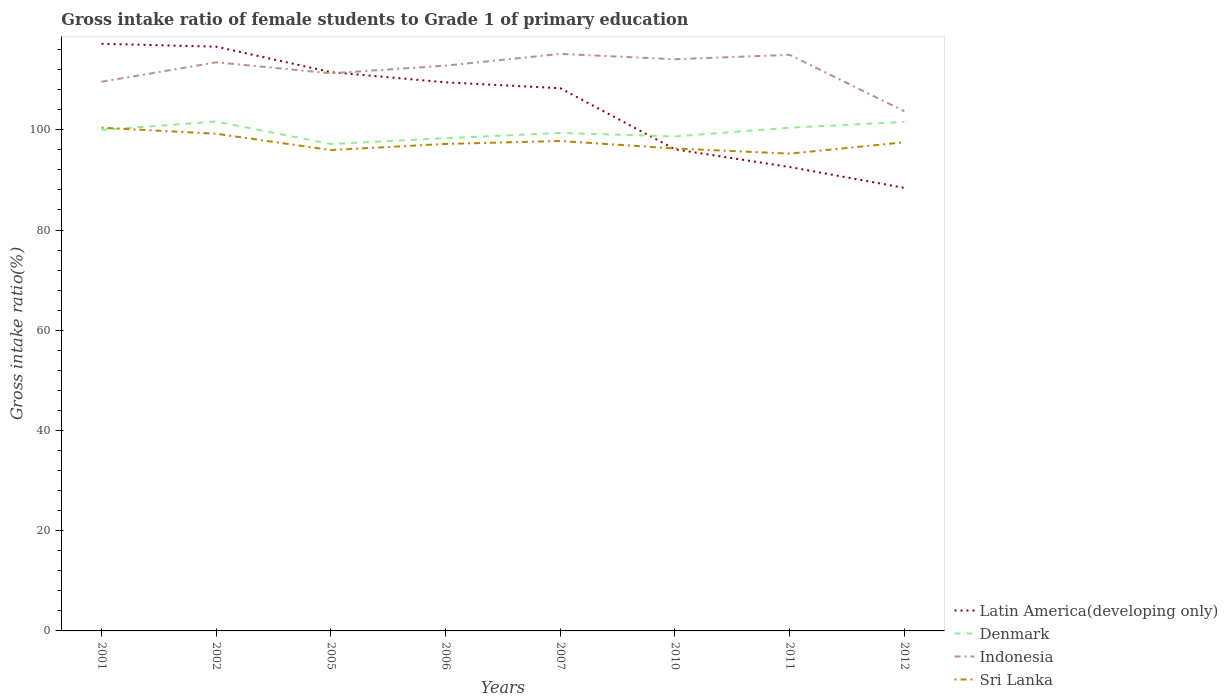Does the line corresponding to Denmark intersect with the line corresponding to Sri Lanka?
Keep it short and to the point. Yes. Across all years, what is the maximum gross intake ratio in Latin America(developing only)?
Your answer should be compact. 88.41. What is the total gross intake ratio in Sri Lanka in the graph?
Provide a short and direct response. 0.71. What is the difference between the highest and the second highest gross intake ratio in Denmark?
Provide a succinct answer. 4.5. What is the difference between the highest and the lowest gross intake ratio in Denmark?
Ensure brevity in your answer.  4. Is the gross intake ratio in Indonesia strictly greater than the gross intake ratio in Sri Lanka over the years?
Offer a very short reply. No. How many lines are there?
Give a very brief answer. 4. What is the difference between two consecutive major ticks on the Y-axis?
Your answer should be very brief. 20. How many legend labels are there?
Your response must be concise. 4. What is the title of the graph?
Give a very brief answer. Gross intake ratio of female students to Grade 1 of primary education. Does "Latin America(all income levels)" appear as one of the legend labels in the graph?
Your answer should be compact. No. What is the label or title of the Y-axis?
Provide a succinct answer. Gross intake ratio(%). What is the Gross intake ratio(%) of Latin America(developing only) in 2001?
Your answer should be very brief. 117.17. What is the Gross intake ratio(%) in Denmark in 2001?
Provide a succinct answer. 99.98. What is the Gross intake ratio(%) of Indonesia in 2001?
Ensure brevity in your answer.  109.59. What is the Gross intake ratio(%) in Sri Lanka in 2001?
Your answer should be very brief. 100.42. What is the Gross intake ratio(%) of Latin America(developing only) in 2002?
Give a very brief answer. 116.59. What is the Gross intake ratio(%) in Denmark in 2002?
Keep it short and to the point. 101.65. What is the Gross intake ratio(%) in Indonesia in 2002?
Provide a succinct answer. 113.46. What is the Gross intake ratio(%) in Sri Lanka in 2002?
Make the answer very short. 99.21. What is the Gross intake ratio(%) in Latin America(developing only) in 2005?
Your answer should be very brief. 111.51. What is the Gross intake ratio(%) in Denmark in 2005?
Your response must be concise. 97.15. What is the Gross intake ratio(%) of Indonesia in 2005?
Keep it short and to the point. 111.28. What is the Gross intake ratio(%) of Sri Lanka in 2005?
Give a very brief answer. 95.96. What is the Gross intake ratio(%) in Latin America(developing only) in 2006?
Keep it short and to the point. 109.47. What is the Gross intake ratio(%) of Denmark in 2006?
Your answer should be very brief. 98.34. What is the Gross intake ratio(%) in Indonesia in 2006?
Ensure brevity in your answer.  112.8. What is the Gross intake ratio(%) of Sri Lanka in 2006?
Your response must be concise. 97.18. What is the Gross intake ratio(%) in Latin America(developing only) in 2007?
Ensure brevity in your answer.  108.3. What is the Gross intake ratio(%) of Denmark in 2007?
Make the answer very short. 99.37. What is the Gross intake ratio(%) of Indonesia in 2007?
Give a very brief answer. 115.14. What is the Gross intake ratio(%) of Sri Lanka in 2007?
Offer a terse response. 97.76. What is the Gross intake ratio(%) in Latin America(developing only) in 2010?
Ensure brevity in your answer.  96.11. What is the Gross intake ratio(%) in Denmark in 2010?
Keep it short and to the point. 98.68. What is the Gross intake ratio(%) in Indonesia in 2010?
Your answer should be compact. 114.08. What is the Gross intake ratio(%) of Sri Lanka in 2010?
Give a very brief answer. 96.27. What is the Gross intake ratio(%) in Latin America(developing only) in 2011?
Your answer should be compact. 92.57. What is the Gross intake ratio(%) in Denmark in 2011?
Ensure brevity in your answer.  100.42. What is the Gross intake ratio(%) of Indonesia in 2011?
Offer a very short reply. 114.96. What is the Gross intake ratio(%) in Sri Lanka in 2011?
Offer a very short reply. 95.25. What is the Gross intake ratio(%) in Latin America(developing only) in 2012?
Ensure brevity in your answer.  88.41. What is the Gross intake ratio(%) of Denmark in 2012?
Give a very brief answer. 101.57. What is the Gross intake ratio(%) in Indonesia in 2012?
Make the answer very short. 103.7. What is the Gross intake ratio(%) of Sri Lanka in 2012?
Your answer should be very brief. 97.51. Across all years, what is the maximum Gross intake ratio(%) in Latin America(developing only)?
Ensure brevity in your answer.  117.17. Across all years, what is the maximum Gross intake ratio(%) of Denmark?
Provide a succinct answer. 101.65. Across all years, what is the maximum Gross intake ratio(%) of Indonesia?
Give a very brief answer. 115.14. Across all years, what is the maximum Gross intake ratio(%) of Sri Lanka?
Your answer should be very brief. 100.42. Across all years, what is the minimum Gross intake ratio(%) in Latin America(developing only)?
Provide a short and direct response. 88.41. Across all years, what is the minimum Gross intake ratio(%) of Denmark?
Give a very brief answer. 97.15. Across all years, what is the minimum Gross intake ratio(%) of Indonesia?
Your answer should be compact. 103.7. Across all years, what is the minimum Gross intake ratio(%) in Sri Lanka?
Offer a very short reply. 95.25. What is the total Gross intake ratio(%) of Latin America(developing only) in the graph?
Offer a very short reply. 840.12. What is the total Gross intake ratio(%) of Denmark in the graph?
Ensure brevity in your answer.  797.16. What is the total Gross intake ratio(%) in Indonesia in the graph?
Provide a succinct answer. 895.02. What is the total Gross intake ratio(%) in Sri Lanka in the graph?
Your response must be concise. 779.56. What is the difference between the Gross intake ratio(%) of Latin America(developing only) in 2001 and that in 2002?
Ensure brevity in your answer.  0.58. What is the difference between the Gross intake ratio(%) in Denmark in 2001 and that in 2002?
Keep it short and to the point. -1.67. What is the difference between the Gross intake ratio(%) in Indonesia in 2001 and that in 2002?
Provide a succinct answer. -3.88. What is the difference between the Gross intake ratio(%) of Sri Lanka in 2001 and that in 2002?
Provide a short and direct response. 1.2. What is the difference between the Gross intake ratio(%) of Latin America(developing only) in 2001 and that in 2005?
Provide a short and direct response. 5.66. What is the difference between the Gross intake ratio(%) of Denmark in 2001 and that in 2005?
Offer a very short reply. 2.82. What is the difference between the Gross intake ratio(%) of Indonesia in 2001 and that in 2005?
Ensure brevity in your answer.  -1.69. What is the difference between the Gross intake ratio(%) in Sri Lanka in 2001 and that in 2005?
Offer a terse response. 4.46. What is the difference between the Gross intake ratio(%) in Latin America(developing only) in 2001 and that in 2006?
Keep it short and to the point. 7.69. What is the difference between the Gross intake ratio(%) in Denmark in 2001 and that in 2006?
Give a very brief answer. 1.64. What is the difference between the Gross intake ratio(%) of Indonesia in 2001 and that in 2006?
Provide a succinct answer. -3.22. What is the difference between the Gross intake ratio(%) in Sri Lanka in 2001 and that in 2006?
Your answer should be very brief. 3.24. What is the difference between the Gross intake ratio(%) of Latin America(developing only) in 2001 and that in 2007?
Make the answer very short. 8.87. What is the difference between the Gross intake ratio(%) in Denmark in 2001 and that in 2007?
Your answer should be compact. 0.6. What is the difference between the Gross intake ratio(%) of Indonesia in 2001 and that in 2007?
Make the answer very short. -5.55. What is the difference between the Gross intake ratio(%) of Sri Lanka in 2001 and that in 2007?
Offer a very short reply. 2.65. What is the difference between the Gross intake ratio(%) of Latin America(developing only) in 2001 and that in 2010?
Provide a succinct answer. 21.06. What is the difference between the Gross intake ratio(%) in Denmark in 2001 and that in 2010?
Make the answer very short. 1.29. What is the difference between the Gross intake ratio(%) in Indonesia in 2001 and that in 2010?
Ensure brevity in your answer.  -4.5. What is the difference between the Gross intake ratio(%) in Sri Lanka in 2001 and that in 2010?
Your response must be concise. 4.15. What is the difference between the Gross intake ratio(%) of Latin America(developing only) in 2001 and that in 2011?
Your response must be concise. 24.59. What is the difference between the Gross intake ratio(%) in Denmark in 2001 and that in 2011?
Ensure brevity in your answer.  -0.45. What is the difference between the Gross intake ratio(%) in Indonesia in 2001 and that in 2011?
Offer a terse response. -5.37. What is the difference between the Gross intake ratio(%) of Sri Lanka in 2001 and that in 2011?
Your answer should be compact. 5.17. What is the difference between the Gross intake ratio(%) of Latin America(developing only) in 2001 and that in 2012?
Your answer should be very brief. 28.75. What is the difference between the Gross intake ratio(%) of Denmark in 2001 and that in 2012?
Offer a very short reply. -1.59. What is the difference between the Gross intake ratio(%) in Indonesia in 2001 and that in 2012?
Offer a very short reply. 5.88. What is the difference between the Gross intake ratio(%) in Sri Lanka in 2001 and that in 2012?
Give a very brief answer. 2.91. What is the difference between the Gross intake ratio(%) in Latin America(developing only) in 2002 and that in 2005?
Your answer should be compact. 5.08. What is the difference between the Gross intake ratio(%) of Denmark in 2002 and that in 2005?
Make the answer very short. 4.5. What is the difference between the Gross intake ratio(%) in Indonesia in 2002 and that in 2005?
Offer a very short reply. 2.19. What is the difference between the Gross intake ratio(%) in Sri Lanka in 2002 and that in 2005?
Keep it short and to the point. 3.25. What is the difference between the Gross intake ratio(%) of Latin America(developing only) in 2002 and that in 2006?
Provide a short and direct response. 7.12. What is the difference between the Gross intake ratio(%) in Denmark in 2002 and that in 2006?
Provide a short and direct response. 3.31. What is the difference between the Gross intake ratio(%) in Indonesia in 2002 and that in 2006?
Your response must be concise. 0.66. What is the difference between the Gross intake ratio(%) of Sri Lanka in 2002 and that in 2006?
Provide a succinct answer. 2.03. What is the difference between the Gross intake ratio(%) of Latin America(developing only) in 2002 and that in 2007?
Provide a short and direct response. 8.29. What is the difference between the Gross intake ratio(%) of Denmark in 2002 and that in 2007?
Give a very brief answer. 2.28. What is the difference between the Gross intake ratio(%) of Indonesia in 2002 and that in 2007?
Give a very brief answer. -1.68. What is the difference between the Gross intake ratio(%) in Sri Lanka in 2002 and that in 2007?
Your answer should be compact. 1.45. What is the difference between the Gross intake ratio(%) in Latin America(developing only) in 2002 and that in 2010?
Offer a very short reply. 20.48. What is the difference between the Gross intake ratio(%) of Denmark in 2002 and that in 2010?
Ensure brevity in your answer.  2.96. What is the difference between the Gross intake ratio(%) of Indonesia in 2002 and that in 2010?
Your answer should be very brief. -0.62. What is the difference between the Gross intake ratio(%) of Sri Lanka in 2002 and that in 2010?
Offer a terse response. 2.95. What is the difference between the Gross intake ratio(%) of Latin America(developing only) in 2002 and that in 2011?
Make the answer very short. 24.01. What is the difference between the Gross intake ratio(%) in Denmark in 2002 and that in 2011?
Provide a short and direct response. 1.22. What is the difference between the Gross intake ratio(%) of Indonesia in 2002 and that in 2011?
Give a very brief answer. -1.49. What is the difference between the Gross intake ratio(%) in Sri Lanka in 2002 and that in 2011?
Offer a very short reply. 3.97. What is the difference between the Gross intake ratio(%) of Latin America(developing only) in 2002 and that in 2012?
Provide a succinct answer. 28.17. What is the difference between the Gross intake ratio(%) of Denmark in 2002 and that in 2012?
Offer a terse response. 0.08. What is the difference between the Gross intake ratio(%) in Indonesia in 2002 and that in 2012?
Keep it short and to the point. 9.76. What is the difference between the Gross intake ratio(%) of Sri Lanka in 2002 and that in 2012?
Your response must be concise. 1.71. What is the difference between the Gross intake ratio(%) of Latin America(developing only) in 2005 and that in 2006?
Provide a succinct answer. 2.04. What is the difference between the Gross intake ratio(%) of Denmark in 2005 and that in 2006?
Ensure brevity in your answer.  -1.18. What is the difference between the Gross intake ratio(%) of Indonesia in 2005 and that in 2006?
Provide a succinct answer. -1.53. What is the difference between the Gross intake ratio(%) of Sri Lanka in 2005 and that in 2006?
Provide a short and direct response. -1.22. What is the difference between the Gross intake ratio(%) in Latin America(developing only) in 2005 and that in 2007?
Offer a very short reply. 3.21. What is the difference between the Gross intake ratio(%) in Denmark in 2005 and that in 2007?
Your response must be concise. -2.22. What is the difference between the Gross intake ratio(%) in Indonesia in 2005 and that in 2007?
Your answer should be compact. -3.87. What is the difference between the Gross intake ratio(%) in Sri Lanka in 2005 and that in 2007?
Keep it short and to the point. -1.8. What is the difference between the Gross intake ratio(%) in Latin America(developing only) in 2005 and that in 2010?
Offer a terse response. 15.4. What is the difference between the Gross intake ratio(%) of Denmark in 2005 and that in 2010?
Make the answer very short. -1.53. What is the difference between the Gross intake ratio(%) in Indonesia in 2005 and that in 2010?
Offer a terse response. -2.81. What is the difference between the Gross intake ratio(%) in Sri Lanka in 2005 and that in 2010?
Offer a very short reply. -0.31. What is the difference between the Gross intake ratio(%) of Latin America(developing only) in 2005 and that in 2011?
Provide a succinct answer. 18.93. What is the difference between the Gross intake ratio(%) in Denmark in 2005 and that in 2011?
Provide a succinct answer. -3.27. What is the difference between the Gross intake ratio(%) of Indonesia in 2005 and that in 2011?
Offer a terse response. -3.68. What is the difference between the Gross intake ratio(%) in Sri Lanka in 2005 and that in 2011?
Offer a very short reply. 0.71. What is the difference between the Gross intake ratio(%) of Latin America(developing only) in 2005 and that in 2012?
Give a very brief answer. 23.1. What is the difference between the Gross intake ratio(%) in Denmark in 2005 and that in 2012?
Make the answer very short. -4.41. What is the difference between the Gross intake ratio(%) in Indonesia in 2005 and that in 2012?
Your answer should be very brief. 7.57. What is the difference between the Gross intake ratio(%) of Sri Lanka in 2005 and that in 2012?
Your response must be concise. -1.54. What is the difference between the Gross intake ratio(%) of Latin America(developing only) in 2006 and that in 2007?
Offer a terse response. 1.17. What is the difference between the Gross intake ratio(%) in Denmark in 2006 and that in 2007?
Provide a short and direct response. -1.04. What is the difference between the Gross intake ratio(%) of Indonesia in 2006 and that in 2007?
Keep it short and to the point. -2.34. What is the difference between the Gross intake ratio(%) of Sri Lanka in 2006 and that in 2007?
Give a very brief answer. -0.58. What is the difference between the Gross intake ratio(%) in Latin America(developing only) in 2006 and that in 2010?
Keep it short and to the point. 13.37. What is the difference between the Gross intake ratio(%) of Denmark in 2006 and that in 2010?
Provide a short and direct response. -0.35. What is the difference between the Gross intake ratio(%) of Indonesia in 2006 and that in 2010?
Your answer should be compact. -1.28. What is the difference between the Gross intake ratio(%) of Sri Lanka in 2006 and that in 2010?
Give a very brief answer. 0.91. What is the difference between the Gross intake ratio(%) in Latin America(developing only) in 2006 and that in 2011?
Offer a very short reply. 16.9. What is the difference between the Gross intake ratio(%) in Denmark in 2006 and that in 2011?
Your answer should be compact. -2.09. What is the difference between the Gross intake ratio(%) in Indonesia in 2006 and that in 2011?
Your response must be concise. -2.15. What is the difference between the Gross intake ratio(%) of Sri Lanka in 2006 and that in 2011?
Offer a very short reply. 1.93. What is the difference between the Gross intake ratio(%) of Latin America(developing only) in 2006 and that in 2012?
Offer a very short reply. 21.06. What is the difference between the Gross intake ratio(%) in Denmark in 2006 and that in 2012?
Provide a short and direct response. -3.23. What is the difference between the Gross intake ratio(%) of Indonesia in 2006 and that in 2012?
Your answer should be very brief. 9.1. What is the difference between the Gross intake ratio(%) in Sri Lanka in 2006 and that in 2012?
Your answer should be very brief. -0.32. What is the difference between the Gross intake ratio(%) of Latin America(developing only) in 2007 and that in 2010?
Make the answer very short. 12.19. What is the difference between the Gross intake ratio(%) in Denmark in 2007 and that in 2010?
Ensure brevity in your answer.  0.69. What is the difference between the Gross intake ratio(%) in Indonesia in 2007 and that in 2010?
Provide a succinct answer. 1.06. What is the difference between the Gross intake ratio(%) in Sri Lanka in 2007 and that in 2010?
Ensure brevity in your answer.  1.49. What is the difference between the Gross intake ratio(%) of Latin America(developing only) in 2007 and that in 2011?
Provide a short and direct response. 15.73. What is the difference between the Gross intake ratio(%) in Denmark in 2007 and that in 2011?
Make the answer very short. -1.05. What is the difference between the Gross intake ratio(%) of Indonesia in 2007 and that in 2011?
Your answer should be very brief. 0.19. What is the difference between the Gross intake ratio(%) of Sri Lanka in 2007 and that in 2011?
Give a very brief answer. 2.52. What is the difference between the Gross intake ratio(%) in Latin America(developing only) in 2007 and that in 2012?
Provide a succinct answer. 19.89. What is the difference between the Gross intake ratio(%) of Denmark in 2007 and that in 2012?
Offer a terse response. -2.2. What is the difference between the Gross intake ratio(%) in Indonesia in 2007 and that in 2012?
Provide a succinct answer. 11.44. What is the difference between the Gross intake ratio(%) of Sri Lanka in 2007 and that in 2012?
Your answer should be compact. 0.26. What is the difference between the Gross intake ratio(%) of Latin America(developing only) in 2010 and that in 2011?
Provide a short and direct response. 3.53. What is the difference between the Gross intake ratio(%) of Denmark in 2010 and that in 2011?
Give a very brief answer. -1.74. What is the difference between the Gross intake ratio(%) of Indonesia in 2010 and that in 2011?
Make the answer very short. -0.87. What is the difference between the Gross intake ratio(%) of Sri Lanka in 2010 and that in 2011?
Provide a succinct answer. 1.02. What is the difference between the Gross intake ratio(%) of Latin America(developing only) in 2010 and that in 2012?
Ensure brevity in your answer.  7.69. What is the difference between the Gross intake ratio(%) of Denmark in 2010 and that in 2012?
Offer a very short reply. -2.88. What is the difference between the Gross intake ratio(%) in Indonesia in 2010 and that in 2012?
Keep it short and to the point. 10.38. What is the difference between the Gross intake ratio(%) in Sri Lanka in 2010 and that in 2012?
Give a very brief answer. -1.24. What is the difference between the Gross intake ratio(%) in Latin America(developing only) in 2011 and that in 2012?
Offer a very short reply. 4.16. What is the difference between the Gross intake ratio(%) in Denmark in 2011 and that in 2012?
Your response must be concise. -1.14. What is the difference between the Gross intake ratio(%) of Indonesia in 2011 and that in 2012?
Your response must be concise. 11.25. What is the difference between the Gross intake ratio(%) in Sri Lanka in 2011 and that in 2012?
Your response must be concise. -2.26. What is the difference between the Gross intake ratio(%) of Latin America(developing only) in 2001 and the Gross intake ratio(%) of Denmark in 2002?
Offer a very short reply. 15.52. What is the difference between the Gross intake ratio(%) in Latin America(developing only) in 2001 and the Gross intake ratio(%) in Indonesia in 2002?
Offer a terse response. 3.7. What is the difference between the Gross intake ratio(%) in Latin America(developing only) in 2001 and the Gross intake ratio(%) in Sri Lanka in 2002?
Provide a succinct answer. 17.95. What is the difference between the Gross intake ratio(%) of Denmark in 2001 and the Gross intake ratio(%) of Indonesia in 2002?
Your answer should be very brief. -13.49. What is the difference between the Gross intake ratio(%) in Denmark in 2001 and the Gross intake ratio(%) in Sri Lanka in 2002?
Your answer should be compact. 0.76. What is the difference between the Gross intake ratio(%) of Indonesia in 2001 and the Gross intake ratio(%) of Sri Lanka in 2002?
Provide a succinct answer. 10.37. What is the difference between the Gross intake ratio(%) in Latin America(developing only) in 2001 and the Gross intake ratio(%) in Denmark in 2005?
Give a very brief answer. 20.01. What is the difference between the Gross intake ratio(%) of Latin America(developing only) in 2001 and the Gross intake ratio(%) of Indonesia in 2005?
Provide a short and direct response. 5.89. What is the difference between the Gross intake ratio(%) in Latin America(developing only) in 2001 and the Gross intake ratio(%) in Sri Lanka in 2005?
Your answer should be very brief. 21.2. What is the difference between the Gross intake ratio(%) of Denmark in 2001 and the Gross intake ratio(%) of Indonesia in 2005?
Keep it short and to the point. -11.3. What is the difference between the Gross intake ratio(%) of Denmark in 2001 and the Gross intake ratio(%) of Sri Lanka in 2005?
Your answer should be very brief. 4.01. What is the difference between the Gross intake ratio(%) of Indonesia in 2001 and the Gross intake ratio(%) of Sri Lanka in 2005?
Your answer should be compact. 13.63. What is the difference between the Gross intake ratio(%) of Latin America(developing only) in 2001 and the Gross intake ratio(%) of Denmark in 2006?
Provide a short and direct response. 18.83. What is the difference between the Gross intake ratio(%) of Latin America(developing only) in 2001 and the Gross intake ratio(%) of Indonesia in 2006?
Your answer should be very brief. 4.36. What is the difference between the Gross intake ratio(%) of Latin America(developing only) in 2001 and the Gross intake ratio(%) of Sri Lanka in 2006?
Keep it short and to the point. 19.98. What is the difference between the Gross intake ratio(%) in Denmark in 2001 and the Gross intake ratio(%) in Indonesia in 2006?
Give a very brief answer. -12.83. What is the difference between the Gross intake ratio(%) of Denmark in 2001 and the Gross intake ratio(%) of Sri Lanka in 2006?
Your answer should be compact. 2.79. What is the difference between the Gross intake ratio(%) of Indonesia in 2001 and the Gross intake ratio(%) of Sri Lanka in 2006?
Offer a very short reply. 12.41. What is the difference between the Gross intake ratio(%) of Latin America(developing only) in 2001 and the Gross intake ratio(%) of Denmark in 2007?
Your response must be concise. 17.79. What is the difference between the Gross intake ratio(%) in Latin America(developing only) in 2001 and the Gross intake ratio(%) in Indonesia in 2007?
Offer a very short reply. 2.02. What is the difference between the Gross intake ratio(%) in Latin America(developing only) in 2001 and the Gross intake ratio(%) in Sri Lanka in 2007?
Your answer should be compact. 19.4. What is the difference between the Gross intake ratio(%) of Denmark in 2001 and the Gross intake ratio(%) of Indonesia in 2007?
Your answer should be very brief. -15.17. What is the difference between the Gross intake ratio(%) of Denmark in 2001 and the Gross intake ratio(%) of Sri Lanka in 2007?
Your answer should be very brief. 2.21. What is the difference between the Gross intake ratio(%) in Indonesia in 2001 and the Gross intake ratio(%) in Sri Lanka in 2007?
Make the answer very short. 11.82. What is the difference between the Gross intake ratio(%) in Latin America(developing only) in 2001 and the Gross intake ratio(%) in Denmark in 2010?
Offer a very short reply. 18.48. What is the difference between the Gross intake ratio(%) in Latin America(developing only) in 2001 and the Gross intake ratio(%) in Indonesia in 2010?
Provide a succinct answer. 3.08. What is the difference between the Gross intake ratio(%) in Latin America(developing only) in 2001 and the Gross intake ratio(%) in Sri Lanka in 2010?
Provide a succinct answer. 20.9. What is the difference between the Gross intake ratio(%) in Denmark in 2001 and the Gross intake ratio(%) in Indonesia in 2010?
Your response must be concise. -14.11. What is the difference between the Gross intake ratio(%) in Denmark in 2001 and the Gross intake ratio(%) in Sri Lanka in 2010?
Make the answer very short. 3.71. What is the difference between the Gross intake ratio(%) of Indonesia in 2001 and the Gross intake ratio(%) of Sri Lanka in 2010?
Offer a very short reply. 13.32. What is the difference between the Gross intake ratio(%) of Latin America(developing only) in 2001 and the Gross intake ratio(%) of Denmark in 2011?
Offer a very short reply. 16.74. What is the difference between the Gross intake ratio(%) of Latin America(developing only) in 2001 and the Gross intake ratio(%) of Indonesia in 2011?
Provide a succinct answer. 2.21. What is the difference between the Gross intake ratio(%) in Latin America(developing only) in 2001 and the Gross intake ratio(%) in Sri Lanka in 2011?
Provide a succinct answer. 21.92. What is the difference between the Gross intake ratio(%) of Denmark in 2001 and the Gross intake ratio(%) of Indonesia in 2011?
Your answer should be very brief. -14.98. What is the difference between the Gross intake ratio(%) of Denmark in 2001 and the Gross intake ratio(%) of Sri Lanka in 2011?
Keep it short and to the point. 4.73. What is the difference between the Gross intake ratio(%) of Indonesia in 2001 and the Gross intake ratio(%) of Sri Lanka in 2011?
Keep it short and to the point. 14.34. What is the difference between the Gross intake ratio(%) of Latin America(developing only) in 2001 and the Gross intake ratio(%) of Denmark in 2012?
Make the answer very short. 15.6. What is the difference between the Gross intake ratio(%) of Latin America(developing only) in 2001 and the Gross intake ratio(%) of Indonesia in 2012?
Offer a terse response. 13.46. What is the difference between the Gross intake ratio(%) of Latin America(developing only) in 2001 and the Gross intake ratio(%) of Sri Lanka in 2012?
Make the answer very short. 19.66. What is the difference between the Gross intake ratio(%) of Denmark in 2001 and the Gross intake ratio(%) of Indonesia in 2012?
Ensure brevity in your answer.  -3.73. What is the difference between the Gross intake ratio(%) in Denmark in 2001 and the Gross intake ratio(%) in Sri Lanka in 2012?
Offer a terse response. 2.47. What is the difference between the Gross intake ratio(%) in Indonesia in 2001 and the Gross intake ratio(%) in Sri Lanka in 2012?
Provide a succinct answer. 12.08. What is the difference between the Gross intake ratio(%) of Latin America(developing only) in 2002 and the Gross intake ratio(%) of Denmark in 2005?
Ensure brevity in your answer.  19.43. What is the difference between the Gross intake ratio(%) in Latin America(developing only) in 2002 and the Gross intake ratio(%) in Indonesia in 2005?
Your response must be concise. 5.31. What is the difference between the Gross intake ratio(%) in Latin America(developing only) in 2002 and the Gross intake ratio(%) in Sri Lanka in 2005?
Provide a short and direct response. 20.63. What is the difference between the Gross intake ratio(%) of Denmark in 2002 and the Gross intake ratio(%) of Indonesia in 2005?
Offer a terse response. -9.63. What is the difference between the Gross intake ratio(%) of Denmark in 2002 and the Gross intake ratio(%) of Sri Lanka in 2005?
Offer a terse response. 5.69. What is the difference between the Gross intake ratio(%) in Indonesia in 2002 and the Gross intake ratio(%) in Sri Lanka in 2005?
Make the answer very short. 17.5. What is the difference between the Gross intake ratio(%) in Latin America(developing only) in 2002 and the Gross intake ratio(%) in Denmark in 2006?
Keep it short and to the point. 18.25. What is the difference between the Gross intake ratio(%) of Latin America(developing only) in 2002 and the Gross intake ratio(%) of Indonesia in 2006?
Ensure brevity in your answer.  3.78. What is the difference between the Gross intake ratio(%) in Latin America(developing only) in 2002 and the Gross intake ratio(%) in Sri Lanka in 2006?
Keep it short and to the point. 19.4. What is the difference between the Gross intake ratio(%) in Denmark in 2002 and the Gross intake ratio(%) in Indonesia in 2006?
Offer a terse response. -11.16. What is the difference between the Gross intake ratio(%) in Denmark in 2002 and the Gross intake ratio(%) in Sri Lanka in 2006?
Offer a very short reply. 4.47. What is the difference between the Gross intake ratio(%) of Indonesia in 2002 and the Gross intake ratio(%) of Sri Lanka in 2006?
Your answer should be compact. 16.28. What is the difference between the Gross intake ratio(%) of Latin America(developing only) in 2002 and the Gross intake ratio(%) of Denmark in 2007?
Give a very brief answer. 17.22. What is the difference between the Gross intake ratio(%) of Latin America(developing only) in 2002 and the Gross intake ratio(%) of Indonesia in 2007?
Keep it short and to the point. 1.44. What is the difference between the Gross intake ratio(%) in Latin America(developing only) in 2002 and the Gross intake ratio(%) in Sri Lanka in 2007?
Your answer should be very brief. 18.82. What is the difference between the Gross intake ratio(%) of Denmark in 2002 and the Gross intake ratio(%) of Indonesia in 2007?
Offer a very short reply. -13.49. What is the difference between the Gross intake ratio(%) in Denmark in 2002 and the Gross intake ratio(%) in Sri Lanka in 2007?
Provide a succinct answer. 3.88. What is the difference between the Gross intake ratio(%) in Indonesia in 2002 and the Gross intake ratio(%) in Sri Lanka in 2007?
Your response must be concise. 15.7. What is the difference between the Gross intake ratio(%) of Latin America(developing only) in 2002 and the Gross intake ratio(%) of Denmark in 2010?
Provide a short and direct response. 17.9. What is the difference between the Gross intake ratio(%) of Latin America(developing only) in 2002 and the Gross intake ratio(%) of Indonesia in 2010?
Ensure brevity in your answer.  2.5. What is the difference between the Gross intake ratio(%) of Latin America(developing only) in 2002 and the Gross intake ratio(%) of Sri Lanka in 2010?
Provide a short and direct response. 20.32. What is the difference between the Gross intake ratio(%) in Denmark in 2002 and the Gross intake ratio(%) in Indonesia in 2010?
Give a very brief answer. -12.44. What is the difference between the Gross intake ratio(%) in Denmark in 2002 and the Gross intake ratio(%) in Sri Lanka in 2010?
Make the answer very short. 5.38. What is the difference between the Gross intake ratio(%) of Indonesia in 2002 and the Gross intake ratio(%) of Sri Lanka in 2010?
Ensure brevity in your answer.  17.19. What is the difference between the Gross intake ratio(%) of Latin America(developing only) in 2002 and the Gross intake ratio(%) of Denmark in 2011?
Offer a very short reply. 16.16. What is the difference between the Gross intake ratio(%) in Latin America(developing only) in 2002 and the Gross intake ratio(%) in Indonesia in 2011?
Keep it short and to the point. 1.63. What is the difference between the Gross intake ratio(%) of Latin America(developing only) in 2002 and the Gross intake ratio(%) of Sri Lanka in 2011?
Provide a succinct answer. 21.34. What is the difference between the Gross intake ratio(%) in Denmark in 2002 and the Gross intake ratio(%) in Indonesia in 2011?
Provide a succinct answer. -13.31. What is the difference between the Gross intake ratio(%) of Indonesia in 2002 and the Gross intake ratio(%) of Sri Lanka in 2011?
Offer a terse response. 18.22. What is the difference between the Gross intake ratio(%) of Latin America(developing only) in 2002 and the Gross intake ratio(%) of Denmark in 2012?
Provide a succinct answer. 15.02. What is the difference between the Gross intake ratio(%) of Latin America(developing only) in 2002 and the Gross intake ratio(%) of Indonesia in 2012?
Give a very brief answer. 12.88. What is the difference between the Gross intake ratio(%) in Latin America(developing only) in 2002 and the Gross intake ratio(%) in Sri Lanka in 2012?
Make the answer very short. 19.08. What is the difference between the Gross intake ratio(%) in Denmark in 2002 and the Gross intake ratio(%) in Indonesia in 2012?
Provide a short and direct response. -2.06. What is the difference between the Gross intake ratio(%) of Denmark in 2002 and the Gross intake ratio(%) of Sri Lanka in 2012?
Keep it short and to the point. 4.14. What is the difference between the Gross intake ratio(%) in Indonesia in 2002 and the Gross intake ratio(%) in Sri Lanka in 2012?
Keep it short and to the point. 15.96. What is the difference between the Gross intake ratio(%) of Latin America(developing only) in 2005 and the Gross intake ratio(%) of Denmark in 2006?
Provide a succinct answer. 13.17. What is the difference between the Gross intake ratio(%) in Latin America(developing only) in 2005 and the Gross intake ratio(%) in Indonesia in 2006?
Offer a very short reply. -1.3. What is the difference between the Gross intake ratio(%) in Latin America(developing only) in 2005 and the Gross intake ratio(%) in Sri Lanka in 2006?
Provide a short and direct response. 14.33. What is the difference between the Gross intake ratio(%) in Denmark in 2005 and the Gross intake ratio(%) in Indonesia in 2006?
Your response must be concise. -15.65. What is the difference between the Gross intake ratio(%) of Denmark in 2005 and the Gross intake ratio(%) of Sri Lanka in 2006?
Keep it short and to the point. -0.03. What is the difference between the Gross intake ratio(%) in Indonesia in 2005 and the Gross intake ratio(%) in Sri Lanka in 2006?
Your answer should be compact. 14.09. What is the difference between the Gross intake ratio(%) of Latin America(developing only) in 2005 and the Gross intake ratio(%) of Denmark in 2007?
Your answer should be very brief. 12.14. What is the difference between the Gross intake ratio(%) of Latin America(developing only) in 2005 and the Gross intake ratio(%) of Indonesia in 2007?
Provide a succinct answer. -3.63. What is the difference between the Gross intake ratio(%) in Latin America(developing only) in 2005 and the Gross intake ratio(%) in Sri Lanka in 2007?
Ensure brevity in your answer.  13.74. What is the difference between the Gross intake ratio(%) in Denmark in 2005 and the Gross intake ratio(%) in Indonesia in 2007?
Your answer should be very brief. -17.99. What is the difference between the Gross intake ratio(%) of Denmark in 2005 and the Gross intake ratio(%) of Sri Lanka in 2007?
Offer a terse response. -0.61. What is the difference between the Gross intake ratio(%) in Indonesia in 2005 and the Gross intake ratio(%) in Sri Lanka in 2007?
Your answer should be compact. 13.51. What is the difference between the Gross intake ratio(%) of Latin America(developing only) in 2005 and the Gross intake ratio(%) of Denmark in 2010?
Provide a short and direct response. 12.82. What is the difference between the Gross intake ratio(%) of Latin America(developing only) in 2005 and the Gross intake ratio(%) of Indonesia in 2010?
Keep it short and to the point. -2.58. What is the difference between the Gross intake ratio(%) of Latin America(developing only) in 2005 and the Gross intake ratio(%) of Sri Lanka in 2010?
Provide a short and direct response. 15.24. What is the difference between the Gross intake ratio(%) in Denmark in 2005 and the Gross intake ratio(%) in Indonesia in 2010?
Keep it short and to the point. -16.93. What is the difference between the Gross intake ratio(%) of Denmark in 2005 and the Gross intake ratio(%) of Sri Lanka in 2010?
Your answer should be compact. 0.88. What is the difference between the Gross intake ratio(%) of Indonesia in 2005 and the Gross intake ratio(%) of Sri Lanka in 2010?
Your answer should be compact. 15.01. What is the difference between the Gross intake ratio(%) of Latin America(developing only) in 2005 and the Gross intake ratio(%) of Denmark in 2011?
Make the answer very short. 11.09. What is the difference between the Gross intake ratio(%) of Latin America(developing only) in 2005 and the Gross intake ratio(%) of Indonesia in 2011?
Keep it short and to the point. -3.45. What is the difference between the Gross intake ratio(%) in Latin America(developing only) in 2005 and the Gross intake ratio(%) in Sri Lanka in 2011?
Offer a very short reply. 16.26. What is the difference between the Gross intake ratio(%) of Denmark in 2005 and the Gross intake ratio(%) of Indonesia in 2011?
Ensure brevity in your answer.  -17.8. What is the difference between the Gross intake ratio(%) in Denmark in 2005 and the Gross intake ratio(%) in Sri Lanka in 2011?
Give a very brief answer. 1.9. What is the difference between the Gross intake ratio(%) in Indonesia in 2005 and the Gross intake ratio(%) in Sri Lanka in 2011?
Provide a short and direct response. 16.03. What is the difference between the Gross intake ratio(%) of Latin America(developing only) in 2005 and the Gross intake ratio(%) of Denmark in 2012?
Your answer should be compact. 9.94. What is the difference between the Gross intake ratio(%) in Latin America(developing only) in 2005 and the Gross intake ratio(%) in Indonesia in 2012?
Your answer should be compact. 7.8. What is the difference between the Gross intake ratio(%) of Latin America(developing only) in 2005 and the Gross intake ratio(%) of Sri Lanka in 2012?
Your answer should be compact. 14. What is the difference between the Gross intake ratio(%) of Denmark in 2005 and the Gross intake ratio(%) of Indonesia in 2012?
Provide a succinct answer. -6.55. What is the difference between the Gross intake ratio(%) in Denmark in 2005 and the Gross intake ratio(%) in Sri Lanka in 2012?
Your response must be concise. -0.35. What is the difference between the Gross intake ratio(%) in Indonesia in 2005 and the Gross intake ratio(%) in Sri Lanka in 2012?
Offer a terse response. 13.77. What is the difference between the Gross intake ratio(%) of Latin America(developing only) in 2006 and the Gross intake ratio(%) of Denmark in 2007?
Provide a short and direct response. 10.1. What is the difference between the Gross intake ratio(%) in Latin America(developing only) in 2006 and the Gross intake ratio(%) in Indonesia in 2007?
Your answer should be very brief. -5.67. What is the difference between the Gross intake ratio(%) in Latin America(developing only) in 2006 and the Gross intake ratio(%) in Sri Lanka in 2007?
Your answer should be compact. 11.71. What is the difference between the Gross intake ratio(%) of Denmark in 2006 and the Gross intake ratio(%) of Indonesia in 2007?
Provide a short and direct response. -16.81. What is the difference between the Gross intake ratio(%) of Denmark in 2006 and the Gross intake ratio(%) of Sri Lanka in 2007?
Provide a succinct answer. 0.57. What is the difference between the Gross intake ratio(%) of Indonesia in 2006 and the Gross intake ratio(%) of Sri Lanka in 2007?
Your response must be concise. 15.04. What is the difference between the Gross intake ratio(%) in Latin America(developing only) in 2006 and the Gross intake ratio(%) in Denmark in 2010?
Your answer should be compact. 10.79. What is the difference between the Gross intake ratio(%) of Latin America(developing only) in 2006 and the Gross intake ratio(%) of Indonesia in 2010?
Keep it short and to the point. -4.61. What is the difference between the Gross intake ratio(%) in Latin America(developing only) in 2006 and the Gross intake ratio(%) in Sri Lanka in 2010?
Keep it short and to the point. 13.2. What is the difference between the Gross intake ratio(%) in Denmark in 2006 and the Gross intake ratio(%) in Indonesia in 2010?
Your answer should be very brief. -15.75. What is the difference between the Gross intake ratio(%) in Denmark in 2006 and the Gross intake ratio(%) in Sri Lanka in 2010?
Provide a succinct answer. 2.07. What is the difference between the Gross intake ratio(%) in Indonesia in 2006 and the Gross intake ratio(%) in Sri Lanka in 2010?
Give a very brief answer. 16.53. What is the difference between the Gross intake ratio(%) of Latin America(developing only) in 2006 and the Gross intake ratio(%) of Denmark in 2011?
Your response must be concise. 9.05. What is the difference between the Gross intake ratio(%) of Latin America(developing only) in 2006 and the Gross intake ratio(%) of Indonesia in 2011?
Give a very brief answer. -5.49. What is the difference between the Gross intake ratio(%) of Latin America(developing only) in 2006 and the Gross intake ratio(%) of Sri Lanka in 2011?
Offer a very short reply. 14.22. What is the difference between the Gross intake ratio(%) of Denmark in 2006 and the Gross intake ratio(%) of Indonesia in 2011?
Your answer should be very brief. -16.62. What is the difference between the Gross intake ratio(%) in Denmark in 2006 and the Gross intake ratio(%) in Sri Lanka in 2011?
Ensure brevity in your answer.  3.09. What is the difference between the Gross intake ratio(%) in Indonesia in 2006 and the Gross intake ratio(%) in Sri Lanka in 2011?
Your answer should be very brief. 17.56. What is the difference between the Gross intake ratio(%) of Latin America(developing only) in 2006 and the Gross intake ratio(%) of Denmark in 2012?
Offer a terse response. 7.9. What is the difference between the Gross intake ratio(%) of Latin America(developing only) in 2006 and the Gross intake ratio(%) of Indonesia in 2012?
Offer a terse response. 5.77. What is the difference between the Gross intake ratio(%) of Latin America(developing only) in 2006 and the Gross intake ratio(%) of Sri Lanka in 2012?
Keep it short and to the point. 11.96. What is the difference between the Gross intake ratio(%) of Denmark in 2006 and the Gross intake ratio(%) of Indonesia in 2012?
Your answer should be very brief. -5.37. What is the difference between the Gross intake ratio(%) of Denmark in 2006 and the Gross intake ratio(%) of Sri Lanka in 2012?
Offer a terse response. 0.83. What is the difference between the Gross intake ratio(%) in Indonesia in 2006 and the Gross intake ratio(%) in Sri Lanka in 2012?
Keep it short and to the point. 15.3. What is the difference between the Gross intake ratio(%) of Latin America(developing only) in 2007 and the Gross intake ratio(%) of Denmark in 2010?
Offer a terse response. 9.61. What is the difference between the Gross intake ratio(%) in Latin America(developing only) in 2007 and the Gross intake ratio(%) in Indonesia in 2010?
Provide a short and direct response. -5.78. What is the difference between the Gross intake ratio(%) of Latin America(developing only) in 2007 and the Gross intake ratio(%) of Sri Lanka in 2010?
Offer a very short reply. 12.03. What is the difference between the Gross intake ratio(%) in Denmark in 2007 and the Gross intake ratio(%) in Indonesia in 2010?
Give a very brief answer. -14.71. What is the difference between the Gross intake ratio(%) of Denmark in 2007 and the Gross intake ratio(%) of Sri Lanka in 2010?
Your answer should be compact. 3.1. What is the difference between the Gross intake ratio(%) of Indonesia in 2007 and the Gross intake ratio(%) of Sri Lanka in 2010?
Ensure brevity in your answer.  18.87. What is the difference between the Gross intake ratio(%) in Latin America(developing only) in 2007 and the Gross intake ratio(%) in Denmark in 2011?
Provide a succinct answer. 7.88. What is the difference between the Gross intake ratio(%) of Latin America(developing only) in 2007 and the Gross intake ratio(%) of Indonesia in 2011?
Your response must be concise. -6.66. What is the difference between the Gross intake ratio(%) of Latin America(developing only) in 2007 and the Gross intake ratio(%) of Sri Lanka in 2011?
Your response must be concise. 13.05. What is the difference between the Gross intake ratio(%) of Denmark in 2007 and the Gross intake ratio(%) of Indonesia in 2011?
Keep it short and to the point. -15.59. What is the difference between the Gross intake ratio(%) in Denmark in 2007 and the Gross intake ratio(%) in Sri Lanka in 2011?
Provide a short and direct response. 4.12. What is the difference between the Gross intake ratio(%) in Indonesia in 2007 and the Gross intake ratio(%) in Sri Lanka in 2011?
Make the answer very short. 19.89. What is the difference between the Gross intake ratio(%) in Latin America(developing only) in 2007 and the Gross intake ratio(%) in Denmark in 2012?
Make the answer very short. 6.73. What is the difference between the Gross intake ratio(%) of Latin America(developing only) in 2007 and the Gross intake ratio(%) of Indonesia in 2012?
Keep it short and to the point. 4.6. What is the difference between the Gross intake ratio(%) of Latin America(developing only) in 2007 and the Gross intake ratio(%) of Sri Lanka in 2012?
Your answer should be very brief. 10.79. What is the difference between the Gross intake ratio(%) in Denmark in 2007 and the Gross intake ratio(%) in Indonesia in 2012?
Your answer should be very brief. -4.33. What is the difference between the Gross intake ratio(%) of Denmark in 2007 and the Gross intake ratio(%) of Sri Lanka in 2012?
Ensure brevity in your answer.  1.87. What is the difference between the Gross intake ratio(%) in Indonesia in 2007 and the Gross intake ratio(%) in Sri Lanka in 2012?
Give a very brief answer. 17.64. What is the difference between the Gross intake ratio(%) in Latin America(developing only) in 2010 and the Gross intake ratio(%) in Denmark in 2011?
Your answer should be very brief. -4.32. What is the difference between the Gross intake ratio(%) of Latin America(developing only) in 2010 and the Gross intake ratio(%) of Indonesia in 2011?
Make the answer very short. -18.85. What is the difference between the Gross intake ratio(%) of Latin America(developing only) in 2010 and the Gross intake ratio(%) of Sri Lanka in 2011?
Keep it short and to the point. 0.86. What is the difference between the Gross intake ratio(%) of Denmark in 2010 and the Gross intake ratio(%) of Indonesia in 2011?
Provide a short and direct response. -16.27. What is the difference between the Gross intake ratio(%) of Denmark in 2010 and the Gross intake ratio(%) of Sri Lanka in 2011?
Offer a terse response. 3.44. What is the difference between the Gross intake ratio(%) in Indonesia in 2010 and the Gross intake ratio(%) in Sri Lanka in 2011?
Ensure brevity in your answer.  18.84. What is the difference between the Gross intake ratio(%) in Latin America(developing only) in 2010 and the Gross intake ratio(%) in Denmark in 2012?
Your answer should be very brief. -5.46. What is the difference between the Gross intake ratio(%) of Latin America(developing only) in 2010 and the Gross intake ratio(%) of Indonesia in 2012?
Your answer should be compact. -7.6. What is the difference between the Gross intake ratio(%) of Latin America(developing only) in 2010 and the Gross intake ratio(%) of Sri Lanka in 2012?
Give a very brief answer. -1.4. What is the difference between the Gross intake ratio(%) in Denmark in 2010 and the Gross intake ratio(%) in Indonesia in 2012?
Provide a short and direct response. -5.02. What is the difference between the Gross intake ratio(%) in Denmark in 2010 and the Gross intake ratio(%) in Sri Lanka in 2012?
Your answer should be compact. 1.18. What is the difference between the Gross intake ratio(%) in Indonesia in 2010 and the Gross intake ratio(%) in Sri Lanka in 2012?
Give a very brief answer. 16.58. What is the difference between the Gross intake ratio(%) of Latin America(developing only) in 2011 and the Gross intake ratio(%) of Denmark in 2012?
Keep it short and to the point. -8.99. What is the difference between the Gross intake ratio(%) of Latin America(developing only) in 2011 and the Gross intake ratio(%) of Indonesia in 2012?
Your answer should be compact. -11.13. What is the difference between the Gross intake ratio(%) in Latin America(developing only) in 2011 and the Gross intake ratio(%) in Sri Lanka in 2012?
Ensure brevity in your answer.  -4.93. What is the difference between the Gross intake ratio(%) of Denmark in 2011 and the Gross intake ratio(%) of Indonesia in 2012?
Your answer should be very brief. -3.28. What is the difference between the Gross intake ratio(%) of Denmark in 2011 and the Gross intake ratio(%) of Sri Lanka in 2012?
Offer a terse response. 2.92. What is the difference between the Gross intake ratio(%) in Indonesia in 2011 and the Gross intake ratio(%) in Sri Lanka in 2012?
Your response must be concise. 17.45. What is the average Gross intake ratio(%) in Latin America(developing only) per year?
Your response must be concise. 105.02. What is the average Gross intake ratio(%) in Denmark per year?
Your answer should be compact. 99.64. What is the average Gross intake ratio(%) of Indonesia per year?
Make the answer very short. 111.88. What is the average Gross intake ratio(%) of Sri Lanka per year?
Make the answer very short. 97.45. In the year 2001, what is the difference between the Gross intake ratio(%) of Latin America(developing only) and Gross intake ratio(%) of Denmark?
Your response must be concise. 17.19. In the year 2001, what is the difference between the Gross intake ratio(%) of Latin America(developing only) and Gross intake ratio(%) of Indonesia?
Give a very brief answer. 7.58. In the year 2001, what is the difference between the Gross intake ratio(%) in Latin America(developing only) and Gross intake ratio(%) in Sri Lanka?
Give a very brief answer. 16.75. In the year 2001, what is the difference between the Gross intake ratio(%) in Denmark and Gross intake ratio(%) in Indonesia?
Make the answer very short. -9.61. In the year 2001, what is the difference between the Gross intake ratio(%) of Denmark and Gross intake ratio(%) of Sri Lanka?
Make the answer very short. -0.44. In the year 2001, what is the difference between the Gross intake ratio(%) of Indonesia and Gross intake ratio(%) of Sri Lanka?
Your answer should be very brief. 9.17. In the year 2002, what is the difference between the Gross intake ratio(%) in Latin America(developing only) and Gross intake ratio(%) in Denmark?
Your answer should be very brief. 14.94. In the year 2002, what is the difference between the Gross intake ratio(%) of Latin America(developing only) and Gross intake ratio(%) of Indonesia?
Make the answer very short. 3.12. In the year 2002, what is the difference between the Gross intake ratio(%) of Latin America(developing only) and Gross intake ratio(%) of Sri Lanka?
Offer a terse response. 17.37. In the year 2002, what is the difference between the Gross intake ratio(%) in Denmark and Gross intake ratio(%) in Indonesia?
Your answer should be compact. -11.82. In the year 2002, what is the difference between the Gross intake ratio(%) of Denmark and Gross intake ratio(%) of Sri Lanka?
Your response must be concise. 2.43. In the year 2002, what is the difference between the Gross intake ratio(%) in Indonesia and Gross intake ratio(%) in Sri Lanka?
Your answer should be compact. 14.25. In the year 2005, what is the difference between the Gross intake ratio(%) in Latin America(developing only) and Gross intake ratio(%) in Denmark?
Your response must be concise. 14.36. In the year 2005, what is the difference between the Gross intake ratio(%) of Latin America(developing only) and Gross intake ratio(%) of Indonesia?
Give a very brief answer. 0.23. In the year 2005, what is the difference between the Gross intake ratio(%) of Latin America(developing only) and Gross intake ratio(%) of Sri Lanka?
Provide a short and direct response. 15.55. In the year 2005, what is the difference between the Gross intake ratio(%) of Denmark and Gross intake ratio(%) of Indonesia?
Give a very brief answer. -14.12. In the year 2005, what is the difference between the Gross intake ratio(%) in Denmark and Gross intake ratio(%) in Sri Lanka?
Make the answer very short. 1.19. In the year 2005, what is the difference between the Gross intake ratio(%) in Indonesia and Gross intake ratio(%) in Sri Lanka?
Provide a succinct answer. 15.31. In the year 2006, what is the difference between the Gross intake ratio(%) in Latin America(developing only) and Gross intake ratio(%) in Denmark?
Keep it short and to the point. 11.13. In the year 2006, what is the difference between the Gross intake ratio(%) in Latin America(developing only) and Gross intake ratio(%) in Indonesia?
Make the answer very short. -3.33. In the year 2006, what is the difference between the Gross intake ratio(%) of Latin America(developing only) and Gross intake ratio(%) of Sri Lanka?
Provide a short and direct response. 12.29. In the year 2006, what is the difference between the Gross intake ratio(%) in Denmark and Gross intake ratio(%) in Indonesia?
Your response must be concise. -14.47. In the year 2006, what is the difference between the Gross intake ratio(%) of Denmark and Gross intake ratio(%) of Sri Lanka?
Your answer should be compact. 1.15. In the year 2006, what is the difference between the Gross intake ratio(%) in Indonesia and Gross intake ratio(%) in Sri Lanka?
Your answer should be compact. 15.62. In the year 2007, what is the difference between the Gross intake ratio(%) in Latin America(developing only) and Gross intake ratio(%) in Denmark?
Your answer should be very brief. 8.93. In the year 2007, what is the difference between the Gross intake ratio(%) in Latin America(developing only) and Gross intake ratio(%) in Indonesia?
Give a very brief answer. -6.84. In the year 2007, what is the difference between the Gross intake ratio(%) in Latin America(developing only) and Gross intake ratio(%) in Sri Lanka?
Provide a short and direct response. 10.53. In the year 2007, what is the difference between the Gross intake ratio(%) in Denmark and Gross intake ratio(%) in Indonesia?
Give a very brief answer. -15.77. In the year 2007, what is the difference between the Gross intake ratio(%) in Denmark and Gross intake ratio(%) in Sri Lanka?
Offer a terse response. 1.61. In the year 2007, what is the difference between the Gross intake ratio(%) in Indonesia and Gross intake ratio(%) in Sri Lanka?
Ensure brevity in your answer.  17.38. In the year 2010, what is the difference between the Gross intake ratio(%) of Latin America(developing only) and Gross intake ratio(%) of Denmark?
Your answer should be very brief. -2.58. In the year 2010, what is the difference between the Gross intake ratio(%) of Latin America(developing only) and Gross intake ratio(%) of Indonesia?
Make the answer very short. -17.98. In the year 2010, what is the difference between the Gross intake ratio(%) of Latin America(developing only) and Gross intake ratio(%) of Sri Lanka?
Keep it short and to the point. -0.16. In the year 2010, what is the difference between the Gross intake ratio(%) in Denmark and Gross intake ratio(%) in Indonesia?
Keep it short and to the point. -15.4. In the year 2010, what is the difference between the Gross intake ratio(%) in Denmark and Gross intake ratio(%) in Sri Lanka?
Your answer should be compact. 2.42. In the year 2010, what is the difference between the Gross intake ratio(%) of Indonesia and Gross intake ratio(%) of Sri Lanka?
Your response must be concise. 17.81. In the year 2011, what is the difference between the Gross intake ratio(%) in Latin America(developing only) and Gross intake ratio(%) in Denmark?
Your response must be concise. -7.85. In the year 2011, what is the difference between the Gross intake ratio(%) of Latin America(developing only) and Gross intake ratio(%) of Indonesia?
Your response must be concise. -22.38. In the year 2011, what is the difference between the Gross intake ratio(%) in Latin America(developing only) and Gross intake ratio(%) in Sri Lanka?
Offer a terse response. -2.67. In the year 2011, what is the difference between the Gross intake ratio(%) in Denmark and Gross intake ratio(%) in Indonesia?
Your response must be concise. -14.53. In the year 2011, what is the difference between the Gross intake ratio(%) of Denmark and Gross intake ratio(%) of Sri Lanka?
Your response must be concise. 5.18. In the year 2011, what is the difference between the Gross intake ratio(%) in Indonesia and Gross intake ratio(%) in Sri Lanka?
Ensure brevity in your answer.  19.71. In the year 2012, what is the difference between the Gross intake ratio(%) in Latin America(developing only) and Gross intake ratio(%) in Denmark?
Offer a terse response. -13.15. In the year 2012, what is the difference between the Gross intake ratio(%) of Latin America(developing only) and Gross intake ratio(%) of Indonesia?
Offer a very short reply. -15.29. In the year 2012, what is the difference between the Gross intake ratio(%) in Latin America(developing only) and Gross intake ratio(%) in Sri Lanka?
Give a very brief answer. -9.09. In the year 2012, what is the difference between the Gross intake ratio(%) in Denmark and Gross intake ratio(%) in Indonesia?
Keep it short and to the point. -2.14. In the year 2012, what is the difference between the Gross intake ratio(%) of Denmark and Gross intake ratio(%) of Sri Lanka?
Keep it short and to the point. 4.06. In the year 2012, what is the difference between the Gross intake ratio(%) in Indonesia and Gross intake ratio(%) in Sri Lanka?
Keep it short and to the point. 6.2. What is the ratio of the Gross intake ratio(%) of Latin America(developing only) in 2001 to that in 2002?
Provide a succinct answer. 1. What is the ratio of the Gross intake ratio(%) in Denmark in 2001 to that in 2002?
Make the answer very short. 0.98. What is the ratio of the Gross intake ratio(%) of Indonesia in 2001 to that in 2002?
Ensure brevity in your answer.  0.97. What is the ratio of the Gross intake ratio(%) of Sri Lanka in 2001 to that in 2002?
Ensure brevity in your answer.  1.01. What is the ratio of the Gross intake ratio(%) in Latin America(developing only) in 2001 to that in 2005?
Give a very brief answer. 1.05. What is the ratio of the Gross intake ratio(%) in Denmark in 2001 to that in 2005?
Offer a terse response. 1.03. What is the ratio of the Gross intake ratio(%) in Sri Lanka in 2001 to that in 2005?
Provide a short and direct response. 1.05. What is the ratio of the Gross intake ratio(%) in Latin America(developing only) in 2001 to that in 2006?
Provide a succinct answer. 1.07. What is the ratio of the Gross intake ratio(%) in Denmark in 2001 to that in 2006?
Offer a very short reply. 1.02. What is the ratio of the Gross intake ratio(%) of Indonesia in 2001 to that in 2006?
Offer a terse response. 0.97. What is the ratio of the Gross intake ratio(%) in Latin America(developing only) in 2001 to that in 2007?
Provide a short and direct response. 1.08. What is the ratio of the Gross intake ratio(%) of Denmark in 2001 to that in 2007?
Offer a very short reply. 1.01. What is the ratio of the Gross intake ratio(%) in Indonesia in 2001 to that in 2007?
Your answer should be very brief. 0.95. What is the ratio of the Gross intake ratio(%) in Sri Lanka in 2001 to that in 2007?
Keep it short and to the point. 1.03. What is the ratio of the Gross intake ratio(%) in Latin America(developing only) in 2001 to that in 2010?
Keep it short and to the point. 1.22. What is the ratio of the Gross intake ratio(%) of Denmark in 2001 to that in 2010?
Offer a very short reply. 1.01. What is the ratio of the Gross intake ratio(%) of Indonesia in 2001 to that in 2010?
Provide a succinct answer. 0.96. What is the ratio of the Gross intake ratio(%) of Sri Lanka in 2001 to that in 2010?
Keep it short and to the point. 1.04. What is the ratio of the Gross intake ratio(%) of Latin America(developing only) in 2001 to that in 2011?
Your response must be concise. 1.27. What is the ratio of the Gross intake ratio(%) of Indonesia in 2001 to that in 2011?
Your answer should be compact. 0.95. What is the ratio of the Gross intake ratio(%) of Sri Lanka in 2001 to that in 2011?
Ensure brevity in your answer.  1.05. What is the ratio of the Gross intake ratio(%) of Latin America(developing only) in 2001 to that in 2012?
Provide a succinct answer. 1.33. What is the ratio of the Gross intake ratio(%) of Denmark in 2001 to that in 2012?
Provide a succinct answer. 0.98. What is the ratio of the Gross intake ratio(%) in Indonesia in 2001 to that in 2012?
Your response must be concise. 1.06. What is the ratio of the Gross intake ratio(%) of Sri Lanka in 2001 to that in 2012?
Give a very brief answer. 1.03. What is the ratio of the Gross intake ratio(%) of Latin America(developing only) in 2002 to that in 2005?
Offer a terse response. 1.05. What is the ratio of the Gross intake ratio(%) of Denmark in 2002 to that in 2005?
Make the answer very short. 1.05. What is the ratio of the Gross intake ratio(%) in Indonesia in 2002 to that in 2005?
Provide a succinct answer. 1.02. What is the ratio of the Gross intake ratio(%) in Sri Lanka in 2002 to that in 2005?
Ensure brevity in your answer.  1.03. What is the ratio of the Gross intake ratio(%) in Latin America(developing only) in 2002 to that in 2006?
Ensure brevity in your answer.  1.06. What is the ratio of the Gross intake ratio(%) in Denmark in 2002 to that in 2006?
Provide a short and direct response. 1.03. What is the ratio of the Gross intake ratio(%) of Indonesia in 2002 to that in 2006?
Give a very brief answer. 1.01. What is the ratio of the Gross intake ratio(%) of Sri Lanka in 2002 to that in 2006?
Give a very brief answer. 1.02. What is the ratio of the Gross intake ratio(%) in Latin America(developing only) in 2002 to that in 2007?
Your answer should be very brief. 1.08. What is the ratio of the Gross intake ratio(%) in Denmark in 2002 to that in 2007?
Your response must be concise. 1.02. What is the ratio of the Gross intake ratio(%) in Indonesia in 2002 to that in 2007?
Keep it short and to the point. 0.99. What is the ratio of the Gross intake ratio(%) in Sri Lanka in 2002 to that in 2007?
Keep it short and to the point. 1.01. What is the ratio of the Gross intake ratio(%) of Latin America(developing only) in 2002 to that in 2010?
Provide a succinct answer. 1.21. What is the ratio of the Gross intake ratio(%) of Sri Lanka in 2002 to that in 2010?
Give a very brief answer. 1.03. What is the ratio of the Gross intake ratio(%) of Latin America(developing only) in 2002 to that in 2011?
Ensure brevity in your answer.  1.26. What is the ratio of the Gross intake ratio(%) in Denmark in 2002 to that in 2011?
Give a very brief answer. 1.01. What is the ratio of the Gross intake ratio(%) of Sri Lanka in 2002 to that in 2011?
Offer a very short reply. 1.04. What is the ratio of the Gross intake ratio(%) in Latin America(developing only) in 2002 to that in 2012?
Provide a succinct answer. 1.32. What is the ratio of the Gross intake ratio(%) in Indonesia in 2002 to that in 2012?
Make the answer very short. 1.09. What is the ratio of the Gross intake ratio(%) in Sri Lanka in 2002 to that in 2012?
Your answer should be very brief. 1.02. What is the ratio of the Gross intake ratio(%) in Latin America(developing only) in 2005 to that in 2006?
Your answer should be very brief. 1.02. What is the ratio of the Gross intake ratio(%) of Denmark in 2005 to that in 2006?
Make the answer very short. 0.99. What is the ratio of the Gross intake ratio(%) in Indonesia in 2005 to that in 2006?
Make the answer very short. 0.99. What is the ratio of the Gross intake ratio(%) in Sri Lanka in 2005 to that in 2006?
Provide a short and direct response. 0.99. What is the ratio of the Gross intake ratio(%) in Latin America(developing only) in 2005 to that in 2007?
Make the answer very short. 1.03. What is the ratio of the Gross intake ratio(%) of Denmark in 2005 to that in 2007?
Ensure brevity in your answer.  0.98. What is the ratio of the Gross intake ratio(%) of Indonesia in 2005 to that in 2007?
Provide a succinct answer. 0.97. What is the ratio of the Gross intake ratio(%) of Sri Lanka in 2005 to that in 2007?
Keep it short and to the point. 0.98. What is the ratio of the Gross intake ratio(%) in Latin America(developing only) in 2005 to that in 2010?
Give a very brief answer. 1.16. What is the ratio of the Gross intake ratio(%) of Denmark in 2005 to that in 2010?
Provide a short and direct response. 0.98. What is the ratio of the Gross intake ratio(%) in Indonesia in 2005 to that in 2010?
Make the answer very short. 0.98. What is the ratio of the Gross intake ratio(%) of Latin America(developing only) in 2005 to that in 2011?
Give a very brief answer. 1.2. What is the ratio of the Gross intake ratio(%) of Denmark in 2005 to that in 2011?
Keep it short and to the point. 0.97. What is the ratio of the Gross intake ratio(%) in Sri Lanka in 2005 to that in 2011?
Give a very brief answer. 1.01. What is the ratio of the Gross intake ratio(%) of Latin America(developing only) in 2005 to that in 2012?
Provide a succinct answer. 1.26. What is the ratio of the Gross intake ratio(%) in Denmark in 2005 to that in 2012?
Offer a terse response. 0.96. What is the ratio of the Gross intake ratio(%) in Indonesia in 2005 to that in 2012?
Provide a succinct answer. 1.07. What is the ratio of the Gross intake ratio(%) in Sri Lanka in 2005 to that in 2012?
Provide a short and direct response. 0.98. What is the ratio of the Gross intake ratio(%) of Latin America(developing only) in 2006 to that in 2007?
Ensure brevity in your answer.  1.01. What is the ratio of the Gross intake ratio(%) in Denmark in 2006 to that in 2007?
Provide a succinct answer. 0.99. What is the ratio of the Gross intake ratio(%) of Indonesia in 2006 to that in 2007?
Provide a short and direct response. 0.98. What is the ratio of the Gross intake ratio(%) in Latin America(developing only) in 2006 to that in 2010?
Your answer should be compact. 1.14. What is the ratio of the Gross intake ratio(%) in Indonesia in 2006 to that in 2010?
Provide a short and direct response. 0.99. What is the ratio of the Gross intake ratio(%) of Sri Lanka in 2006 to that in 2010?
Your answer should be compact. 1.01. What is the ratio of the Gross intake ratio(%) of Latin America(developing only) in 2006 to that in 2011?
Your answer should be compact. 1.18. What is the ratio of the Gross intake ratio(%) in Denmark in 2006 to that in 2011?
Provide a succinct answer. 0.98. What is the ratio of the Gross intake ratio(%) of Indonesia in 2006 to that in 2011?
Ensure brevity in your answer.  0.98. What is the ratio of the Gross intake ratio(%) in Sri Lanka in 2006 to that in 2011?
Offer a very short reply. 1.02. What is the ratio of the Gross intake ratio(%) in Latin America(developing only) in 2006 to that in 2012?
Make the answer very short. 1.24. What is the ratio of the Gross intake ratio(%) in Denmark in 2006 to that in 2012?
Provide a succinct answer. 0.97. What is the ratio of the Gross intake ratio(%) in Indonesia in 2006 to that in 2012?
Offer a very short reply. 1.09. What is the ratio of the Gross intake ratio(%) of Latin America(developing only) in 2007 to that in 2010?
Your response must be concise. 1.13. What is the ratio of the Gross intake ratio(%) in Indonesia in 2007 to that in 2010?
Your answer should be compact. 1.01. What is the ratio of the Gross intake ratio(%) in Sri Lanka in 2007 to that in 2010?
Ensure brevity in your answer.  1.02. What is the ratio of the Gross intake ratio(%) of Latin America(developing only) in 2007 to that in 2011?
Ensure brevity in your answer.  1.17. What is the ratio of the Gross intake ratio(%) in Indonesia in 2007 to that in 2011?
Offer a very short reply. 1. What is the ratio of the Gross intake ratio(%) in Sri Lanka in 2007 to that in 2011?
Your response must be concise. 1.03. What is the ratio of the Gross intake ratio(%) in Latin America(developing only) in 2007 to that in 2012?
Provide a succinct answer. 1.22. What is the ratio of the Gross intake ratio(%) in Denmark in 2007 to that in 2012?
Give a very brief answer. 0.98. What is the ratio of the Gross intake ratio(%) in Indonesia in 2007 to that in 2012?
Your answer should be very brief. 1.11. What is the ratio of the Gross intake ratio(%) in Latin America(developing only) in 2010 to that in 2011?
Your answer should be compact. 1.04. What is the ratio of the Gross intake ratio(%) in Denmark in 2010 to that in 2011?
Make the answer very short. 0.98. What is the ratio of the Gross intake ratio(%) in Indonesia in 2010 to that in 2011?
Your answer should be very brief. 0.99. What is the ratio of the Gross intake ratio(%) in Sri Lanka in 2010 to that in 2011?
Keep it short and to the point. 1.01. What is the ratio of the Gross intake ratio(%) in Latin America(developing only) in 2010 to that in 2012?
Your response must be concise. 1.09. What is the ratio of the Gross intake ratio(%) of Denmark in 2010 to that in 2012?
Your answer should be compact. 0.97. What is the ratio of the Gross intake ratio(%) of Indonesia in 2010 to that in 2012?
Provide a succinct answer. 1.1. What is the ratio of the Gross intake ratio(%) in Sri Lanka in 2010 to that in 2012?
Offer a very short reply. 0.99. What is the ratio of the Gross intake ratio(%) in Latin America(developing only) in 2011 to that in 2012?
Your response must be concise. 1.05. What is the ratio of the Gross intake ratio(%) of Denmark in 2011 to that in 2012?
Provide a short and direct response. 0.99. What is the ratio of the Gross intake ratio(%) of Indonesia in 2011 to that in 2012?
Keep it short and to the point. 1.11. What is the ratio of the Gross intake ratio(%) of Sri Lanka in 2011 to that in 2012?
Make the answer very short. 0.98. What is the difference between the highest and the second highest Gross intake ratio(%) of Latin America(developing only)?
Give a very brief answer. 0.58. What is the difference between the highest and the second highest Gross intake ratio(%) in Denmark?
Your answer should be compact. 0.08. What is the difference between the highest and the second highest Gross intake ratio(%) of Indonesia?
Provide a succinct answer. 0.19. What is the difference between the highest and the second highest Gross intake ratio(%) of Sri Lanka?
Your answer should be very brief. 1.2. What is the difference between the highest and the lowest Gross intake ratio(%) in Latin America(developing only)?
Provide a short and direct response. 28.75. What is the difference between the highest and the lowest Gross intake ratio(%) of Denmark?
Make the answer very short. 4.5. What is the difference between the highest and the lowest Gross intake ratio(%) in Indonesia?
Ensure brevity in your answer.  11.44. What is the difference between the highest and the lowest Gross intake ratio(%) in Sri Lanka?
Provide a succinct answer. 5.17. 